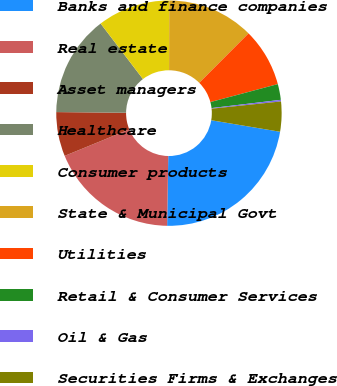Convert chart to OTSL. <chart><loc_0><loc_0><loc_500><loc_500><pie_chart><fcel>Banks and finance companies<fcel>Real estate<fcel>Asset managers<fcel>Healthcare<fcel>Consumer products<fcel>State & Municipal Govt<fcel>Utilities<fcel>Retail & Consumer Services<fcel>Oil & Gas<fcel>Securities Firms & Exchanges<nl><fcel>22.62%<fcel>18.55%<fcel>6.34%<fcel>14.48%<fcel>10.41%<fcel>12.44%<fcel>8.37%<fcel>2.26%<fcel>0.23%<fcel>4.3%<nl></chart> 